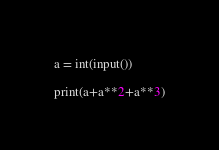<code> <loc_0><loc_0><loc_500><loc_500><_Python_>a = int(input())

print(a+a**2+a**3)
</code> 